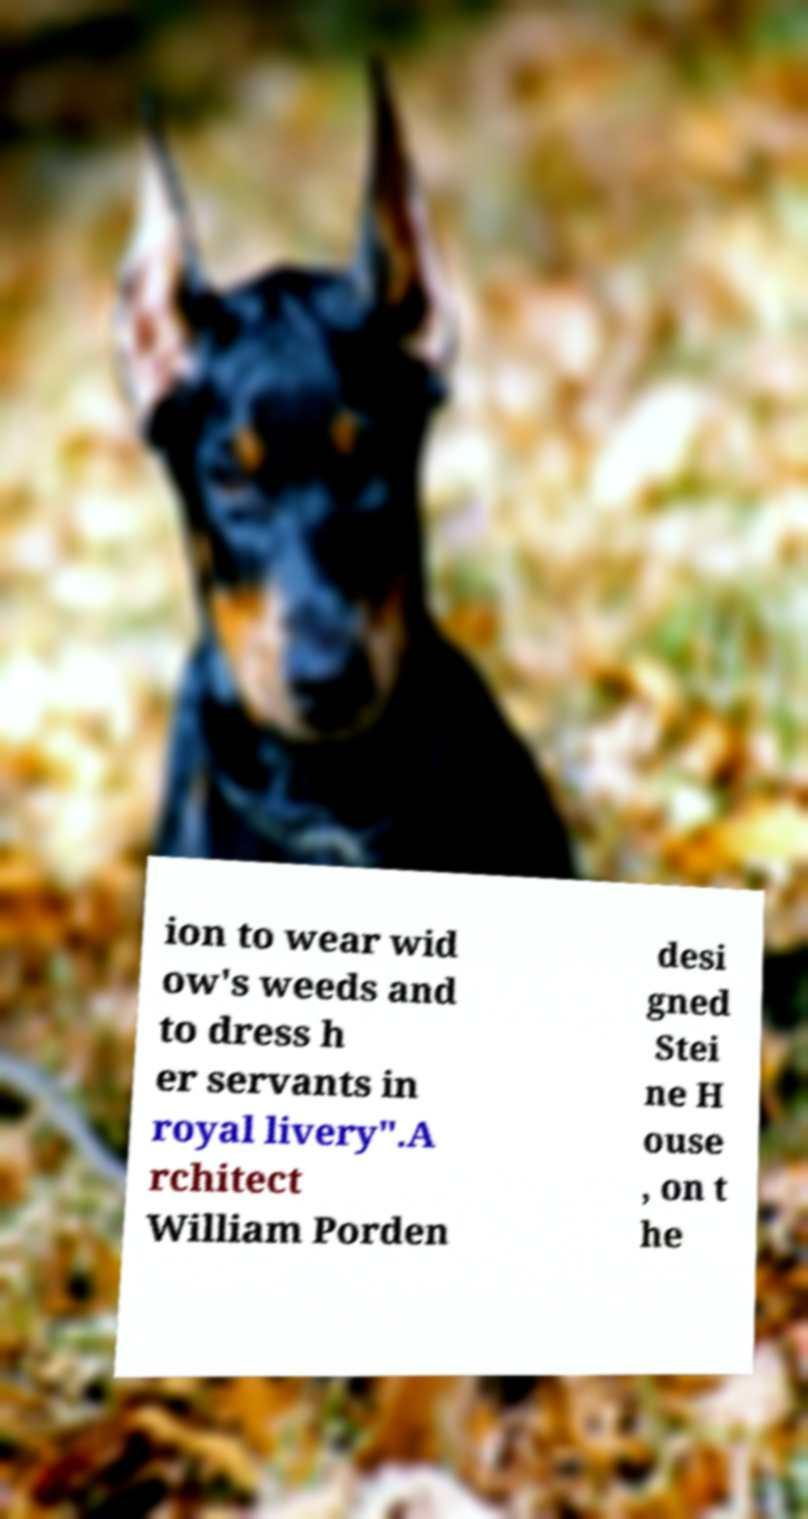For documentation purposes, I need the text within this image transcribed. Could you provide that? ion to wear wid ow's weeds and to dress h er servants in royal livery".A rchitect William Porden desi gned Stei ne H ouse , on t he 